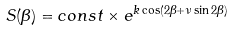Convert formula to latex. <formula><loc_0><loc_0><loc_500><loc_500>S ( \beta ) = c o n s t \times e ^ { k \cos ( 2 \beta + \nu \sin 2 \beta ) }</formula> 